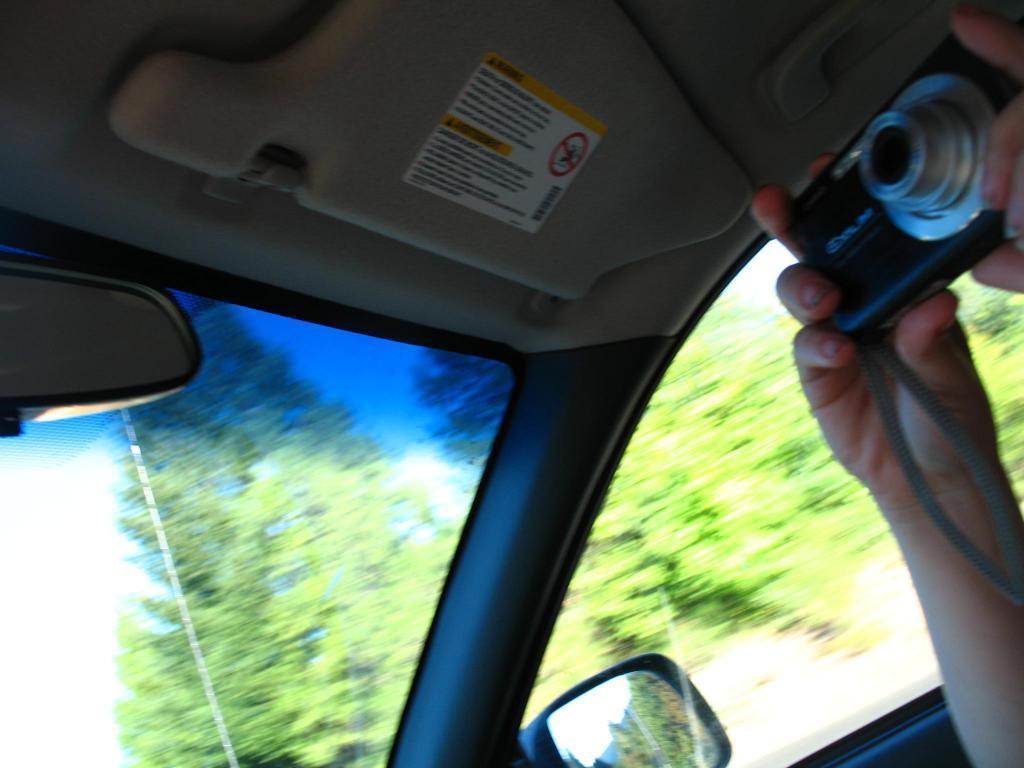Can you describe this image briefly? This image is taken from a car. A person is holding a camera and there are trees at the back. 